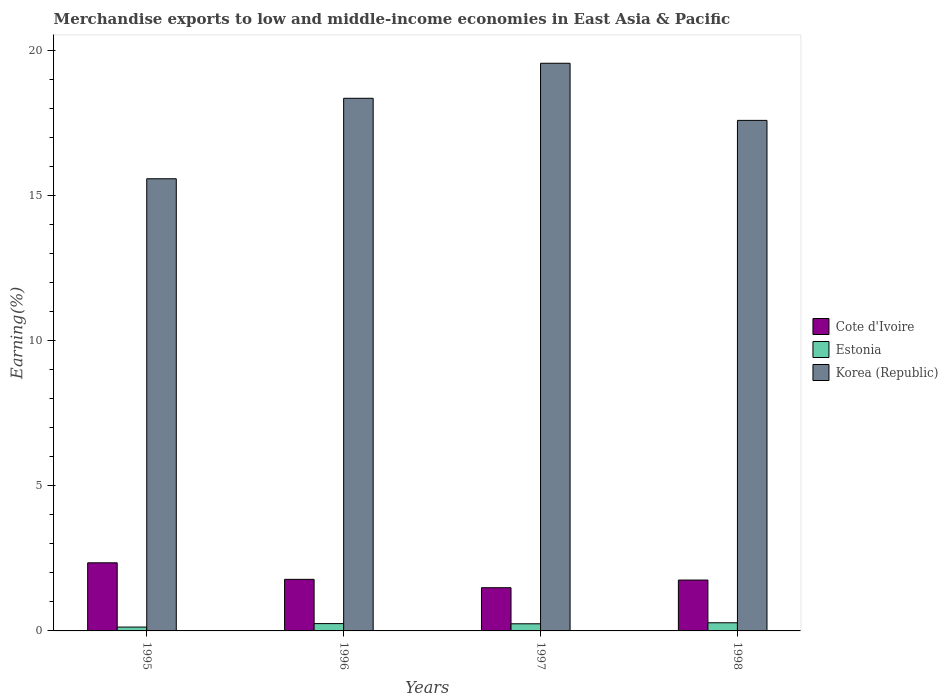How many different coloured bars are there?
Your answer should be compact. 3. How many groups of bars are there?
Offer a terse response. 4. Are the number of bars per tick equal to the number of legend labels?
Your answer should be very brief. Yes. How many bars are there on the 2nd tick from the left?
Provide a short and direct response. 3. What is the label of the 1st group of bars from the left?
Provide a succinct answer. 1995. In how many cases, is the number of bars for a given year not equal to the number of legend labels?
Keep it short and to the point. 0. What is the percentage of amount earned from merchandise exports in Cote d'Ivoire in 1998?
Ensure brevity in your answer.  1.75. Across all years, what is the maximum percentage of amount earned from merchandise exports in Estonia?
Your response must be concise. 0.28. Across all years, what is the minimum percentage of amount earned from merchandise exports in Korea (Republic)?
Ensure brevity in your answer.  15.59. What is the total percentage of amount earned from merchandise exports in Korea (Republic) in the graph?
Give a very brief answer. 71.12. What is the difference between the percentage of amount earned from merchandise exports in Korea (Republic) in 1995 and that in 1998?
Provide a succinct answer. -2.01. What is the difference between the percentage of amount earned from merchandise exports in Cote d'Ivoire in 1996 and the percentage of amount earned from merchandise exports in Korea (Republic) in 1995?
Give a very brief answer. -13.81. What is the average percentage of amount earned from merchandise exports in Korea (Republic) per year?
Provide a succinct answer. 17.78. In the year 1996, what is the difference between the percentage of amount earned from merchandise exports in Korea (Republic) and percentage of amount earned from merchandise exports in Cote d'Ivoire?
Give a very brief answer. 16.58. In how many years, is the percentage of amount earned from merchandise exports in Cote d'Ivoire greater than 13 %?
Offer a very short reply. 0. What is the ratio of the percentage of amount earned from merchandise exports in Korea (Republic) in 1997 to that in 1998?
Your answer should be compact. 1.11. Is the percentage of amount earned from merchandise exports in Estonia in 1996 less than that in 1998?
Provide a short and direct response. Yes. What is the difference between the highest and the second highest percentage of amount earned from merchandise exports in Korea (Republic)?
Offer a terse response. 1.21. What is the difference between the highest and the lowest percentage of amount earned from merchandise exports in Cote d'Ivoire?
Keep it short and to the point. 0.86. In how many years, is the percentage of amount earned from merchandise exports in Cote d'Ivoire greater than the average percentage of amount earned from merchandise exports in Cote d'Ivoire taken over all years?
Provide a succinct answer. 1. What does the 2nd bar from the left in 1995 represents?
Your answer should be very brief. Estonia. What does the 2nd bar from the right in 1997 represents?
Make the answer very short. Estonia. How many bars are there?
Provide a succinct answer. 12. Are all the bars in the graph horizontal?
Make the answer very short. No. What is the difference between two consecutive major ticks on the Y-axis?
Provide a short and direct response. 5. Does the graph contain grids?
Your answer should be compact. No. Where does the legend appear in the graph?
Your answer should be compact. Center right. How are the legend labels stacked?
Give a very brief answer. Vertical. What is the title of the graph?
Your answer should be very brief. Merchandise exports to low and middle-income economies in East Asia & Pacific. Does "Turkey" appear as one of the legend labels in the graph?
Give a very brief answer. No. What is the label or title of the X-axis?
Offer a terse response. Years. What is the label or title of the Y-axis?
Give a very brief answer. Earning(%). What is the Earning(%) in Cote d'Ivoire in 1995?
Provide a short and direct response. 2.35. What is the Earning(%) in Estonia in 1995?
Offer a very short reply. 0.13. What is the Earning(%) in Korea (Republic) in 1995?
Offer a terse response. 15.59. What is the Earning(%) of Cote d'Ivoire in 1996?
Ensure brevity in your answer.  1.78. What is the Earning(%) in Estonia in 1996?
Offer a terse response. 0.25. What is the Earning(%) in Korea (Republic) in 1996?
Your response must be concise. 18.36. What is the Earning(%) of Cote d'Ivoire in 1997?
Make the answer very short. 1.49. What is the Earning(%) of Estonia in 1997?
Make the answer very short. 0.25. What is the Earning(%) of Korea (Republic) in 1997?
Ensure brevity in your answer.  19.57. What is the Earning(%) in Cote d'Ivoire in 1998?
Your answer should be compact. 1.75. What is the Earning(%) of Estonia in 1998?
Make the answer very short. 0.28. What is the Earning(%) in Korea (Republic) in 1998?
Keep it short and to the point. 17.6. Across all years, what is the maximum Earning(%) in Cote d'Ivoire?
Your answer should be compact. 2.35. Across all years, what is the maximum Earning(%) in Estonia?
Ensure brevity in your answer.  0.28. Across all years, what is the maximum Earning(%) of Korea (Republic)?
Ensure brevity in your answer.  19.57. Across all years, what is the minimum Earning(%) of Cote d'Ivoire?
Offer a very short reply. 1.49. Across all years, what is the minimum Earning(%) in Estonia?
Provide a short and direct response. 0.13. Across all years, what is the minimum Earning(%) in Korea (Republic)?
Your answer should be compact. 15.59. What is the total Earning(%) of Cote d'Ivoire in the graph?
Give a very brief answer. 7.37. What is the total Earning(%) of Estonia in the graph?
Provide a succinct answer. 0.91. What is the total Earning(%) of Korea (Republic) in the graph?
Offer a very short reply. 71.12. What is the difference between the Earning(%) of Cote d'Ivoire in 1995 and that in 1996?
Offer a terse response. 0.57. What is the difference between the Earning(%) of Estonia in 1995 and that in 1996?
Your response must be concise. -0.12. What is the difference between the Earning(%) of Korea (Republic) in 1995 and that in 1996?
Make the answer very short. -2.77. What is the difference between the Earning(%) of Cote d'Ivoire in 1995 and that in 1997?
Your response must be concise. 0.86. What is the difference between the Earning(%) in Estonia in 1995 and that in 1997?
Offer a terse response. -0.11. What is the difference between the Earning(%) in Korea (Republic) in 1995 and that in 1997?
Give a very brief answer. -3.98. What is the difference between the Earning(%) in Cote d'Ivoire in 1995 and that in 1998?
Keep it short and to the point. 0.59. What is the difference between the Earning(%) of Estonia in 1995 and that in 1998?
Provide a succinct answer. -0.15. What is the difference between the Earning(%) of Korea (Republic) in 1995 and that in 1998?
Your answer should be very brief. -2.01. What is the difference between the Earning(%) in Cote d'Ivoire in 1996 and that in 1997?
Make the answer very short. 0.29. What is the difference between the Earning(%) in Estonia in 1996 and that in 1997?
Your answer should be very brief. 0.01. What is the difference between the Earning(%) in Korea (Republic) in 1996 and that in 1997?
Offer a terse response. -1.21. What is the difference between the Earning(%) in Cote d'Ivoire in 1996 and that in 1998?
Keep it short and to the point. 0.02. What is the difference between the Earning(%) in Estonia in 1996 and that in 1998?
Offer a very short reply. -0.03. What is the difference between the Earning(%) in Korea (Republic) in 1996 and that in 1998?
Offer a very short reply. 0.76. What is the difference between the Earning(%) in Cote d'Ivoire in 1997 and that in 1998?
Your answer should be very brief. -0.26. What is the difference between the Earning(%) in Estonia in 1997 and that in 1998?
Provide a short and direct response. -0.04. What is the difference between the Earning(%) of Korea (Republic) in 1997 and that in 1998?
Ensure brevity in your answer.  1.97. What is the difference between the Earning(%) in Cote d'Ivoire in 1995 and the Earning(%) in Estonia in 1996?
Your response must be concise. 2.1. What is the difference between the Earning(%) in Cote d'Ivoire in 1995 and the Earning(%) in Korea (Republic) in 1996?
Offer a very short reply. -16.01. What is the difference between the Earning(%) of Estonia in 1995 and the Earning(%) of Korea (Republic) in 1996?
Offer a very short reply. -18.23. What is the difference between the Earning(%) in Cote d'Ivoire in 1995 and the Earning(%) in Estonia in 1997?
Give a very brief answer. 2.1. What is the difference between the Earning(%) in Cote d'Ivoire in 1995 and the Earning(%) in Korea (Republic) in 1997?
Offer a terse response. -17.22. What is the difference between the Earning(%) in Estonia in 1995 and the Earning(%) in Korea (Republic) in 1997?
Offer a terse response. -19.44. What is the difference between the Earning(%) of Cote d'Ivoire in 1995 and the Earning(%) of Estonia in 1998?
Provide a short and direct response. 2.07. What is the difference between the Earning(%) in Cote d'Ivoire in 1995 and the Earning(%) in Korea (Republic) in 1998?
Your response must be concise. -15.25. What is the difference between the Earning(%) in Estonia in 1995 and the Earning(%) in Korea (Republic) in 1998?
Make the answer very short. -17.47. What is the difference between the Earning(%) of Cote d'Ivoire in 1996 and the Earning(%) of Estonia in 1997?
Keep it short and to the point. 1.53. What is the difference between the Earning(%) of Cote d'Ivoire in 1996 and the Earning(%) of Korea (Republic) in 1997?
Offer a very short reply. -17.79. What is the difference between the Earning(%) of Estonia in 1996 and the Earning(%) of Korea (Republic) in 1997?
Your answer should be very brief. -19.32. What is the difference between the Earning(%) of Cote d'Ivoire in 1996 and the Earning(%) of Estonia in 1998?
Offer a very short reply. 1.5. What is the difference between the Earning(%) of Cote d'Ivoire in 1996 and the Earning(%) of Korea (Republic) in 1998?
Your answer should be compact. -15.82. What is the difference between the Earning(%) of Estonia in 1996 and the Earning(%) of Korea (Republic) in 1998?
Keep it short and to the point. -17.35. What is the difference between the Earning(%) in Cote d'Ivoire in 1997 and the Earning(%) in Estonia in 1998?
Your answer should be compact. 1.21. What is the difference between the Earning(%) of Cote d'Ivoire in 1997 and the Earning(%) of Korea (Republic) in 1998?
Ensure brevity in your answer.  -16.11. What is the difference between the Earning(%) of Estonia in 1997 and the Earning(%) of Korea (Republic) in 1998?
Ensure brevity in your answer.  -17.35. What is the average Earning(%) of Cote d'Ivoire per year?
Keep it short and to the point. 1.84. What is the average Earning(%) of Estonia per year?
Make the answer very short. 0.23. What is the average Earning(%) in Korea (Republic) per year?
Provide a short and direct response. 17.78. In the year 1995, what is the difference between the Earning(%) in Cote d'Ivoire and Earning(%) in Estonia?
Ensure brevity in your answer.  2.22. In the year 1995, what is the difference between the Earning(%) of Cote d'Ivoire and Earning(%) of Korea (Republic)?
Keep it short and to the point. -13.24. In the year 1995, what is the difference between the Earning(%) in Estonia and Earning(%) in Korea (Republic)?
Your answer should be very brief. -15.46. In the year 1996, what is the difference between the Earning(%) of Cote d'Ivoire and Earning(%) of Estonia?
Offer a terse response. 1.53. In the year 1996, what is the difference between the Earning(%) of Cote d'Ivoire and Earning(%) of Korea (Republic)?
Ensure brevity in your answer.  -16.58. In the year 1996, what is the difference between the Earning(%) of Estonia and Earning(%) of Korea (Republic)?
Make the answer very short. -18.11. In the year 1997, what is the difference between the Earning(%) of Cote d'Ivoire and Earning(%) of Estonia?
Provide a short and direct response. 1.24. In the year 1997, what is the difference between the Earning(%) of Cote d'Ivoire and Earning(%) of Korea (Republic)?
Ensure brevity in your answer.  -18.08. In the year 1997, what is the difference between the Earning(%) in Estonia and Earning(%) in Korea (Republic)?
Offer a terse response. -19.32. In the year 1998, what is the difference between the Earning(%) of Cote d'Ivoire and Earning(%) of Estonia?
Make the answer very short. 1.47. In the year 1998, what is the difference between the Earning(%) in Cote d'Ivoire and Earning(%) in Korea (Republic)?
Offer a very short reply. -15.85. In the year 1998, what is the difference between the Earning(%) in Estonia and Earning(%) in Korea (Republic)?
Your answer should be compact. -17.32. What is the ratio of the Earning(%) in Cote d'Ivoire in 1995 to that in 1996?
Your answer should be very brief. 1.32. What is the ratio of the Earning(%) of Estonia in 1995 to that in 1996?
Ensure brevity in your answer.  0.52. What is the ratio of the Earning(%) in Korea (Republic) in 1995 to that in 1996?
Offer a very short reply. 0.85. What is the ratio of the Earning(%) of Cote d'Ivoire in 1995 to that in 1997?
Provide a succinct answer. 1.58. What is the ratio of the Earning(%) of Estonia in 1995 to that in 1997?
Keep it short and to the point. 0.54. What is the ratio of the Earning(%) of Korea (Republic) in 1995 to that in 1997?
Offer a very short reply. 0.8. What is the ratio of the Earning(%) in Cote d'Ivoire in 1995 to that in 1998?
Provide a short and direct response. 1.34. What is the ratio of the Earning(%) in Estonia in 1995 to that in 1998?
Your answer should be very brief. 0.47. What is the ratio of the Earning(%) in Korea (Republic) in 1995 to that in 1998?
Offer a terse response. 0.89. What is the ratio of the Earning(%) of Cote d'Ivoire in 1996 to that in 1997?
Ensure brevity in your answer.  1.19. What is the ratio of the Earning(%) in Estonia in 1996 to that in 1997?
Offer a very short reply. 1.03. What is the ratio of the Earning(%) of Korea (Republic) in 1996 to that in 1997?
Provide a short and direct response. 0.94. What is the ratio of the Earning(%) in Cote d'Ivoire in 1996 to that in 1998?
Make the answer very short. 1.01. What is the ratio of the Earning(%) in Estonia in 1996 to that in 1998?
Keep it short and to the point. 0.9. What is the ratio of the Earning(%) of Korea (Republic) in 1996 to that in 1998?
Ensure brevity in your answer.  1.04. What is the ratio of the Earning(%) of Cote d'Ivoire in 1997 to that in 1998?
Provide a short and direct response. 0.85. What is the ratio of the Earning(%) in Estonia in 1997 to that in 1998?
Offer a terse response. 0.87. What is the ratio of the Earning(%) in Korea (Republic) in 1997 to that in 1998?
Offer a very short reply. 1.11. What is the difference between the highest and the second highest Earning(%) of Cote d'Ivoire?
Make the answer very short. 0.57. What is the difference between the highest and the second highest Earning(%) in Estonia?
Your response must be concise. 0.03. What is the difference between the highest and the second highest Earning(%) in Korea (Republic)?
Make the answer very short. 1.21. What is the difference between the highest and the lowest Earning(%) of Cote d'Ivoire?
Your answer should be compact. 0.86. What is the difference between the highest and the lowest Earning(%) in Estonia?
Ensure brevity in your answer.  0.15. What is the difference between the highest and the lowest Earning(%) of Korea (Republic)?
Keep it short and to the point. 3.98. 